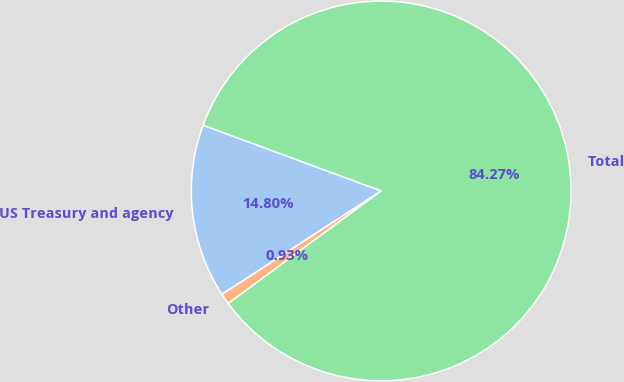Convert chart to OTSL. <chart><loc_0><loc_0><loc_500><loc_500><pie_chart><fcel>US Treasury and agency<fcel>Other<fcel>Total<nl><fcel>14.8%<fcel>0.93%<fcel>84.27%<nl></chart> 